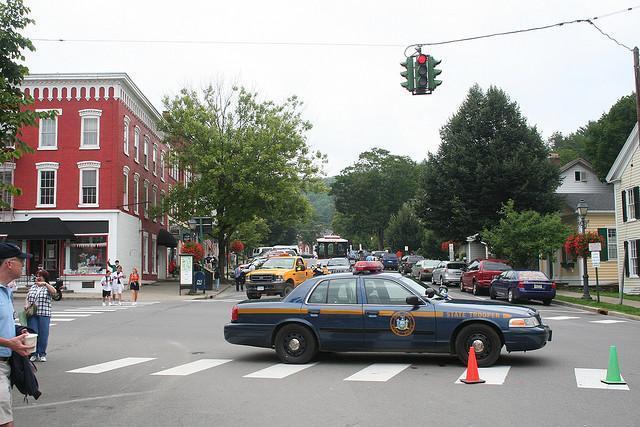How many cars can you see?
Give a very brief answer. 2. 